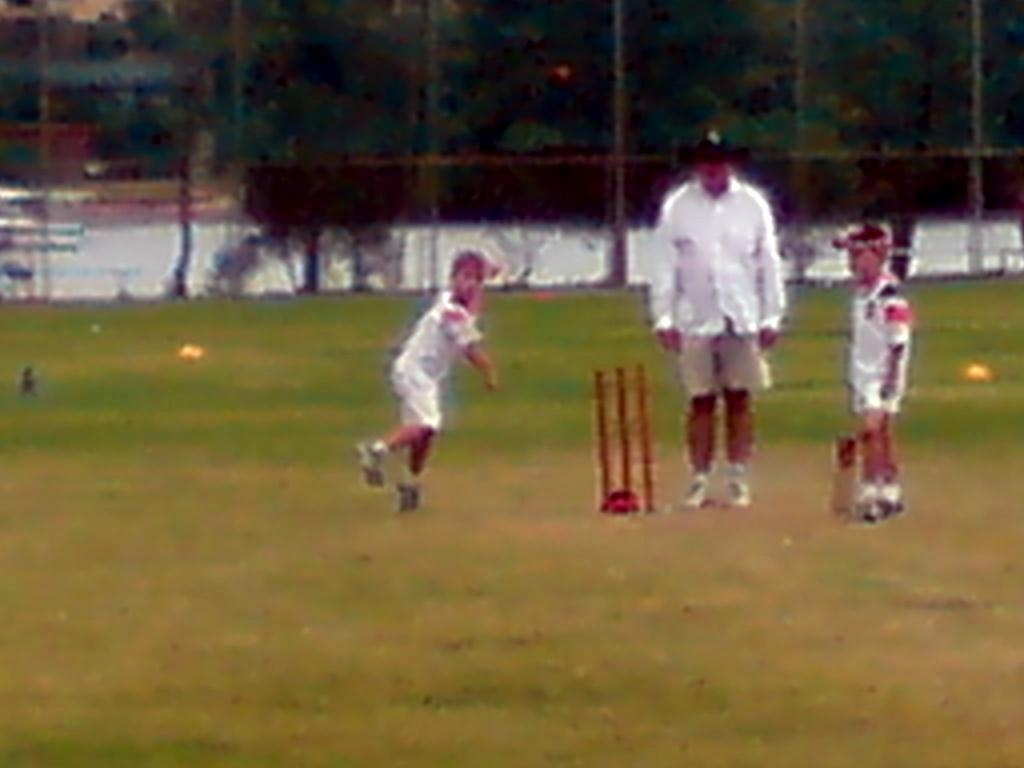How many kids are in the image? There are two kids in the image. Who else is present in the image besides the kids? There is a man in the image. What is the surface on which the people are standing? The people are standing on the ground. What can be seen in the image that is related to a sport? There are wickets in the image, which are used in the sport of cricket. What is visible in the background of the image? There is a blurred image in the background, which contains fencing and trees. What type of sail can be seen in the image? There is no sail present in the image. Who is the representative of the group in the image? The image does not depict a group or a representative; it shows two kids and a man. 